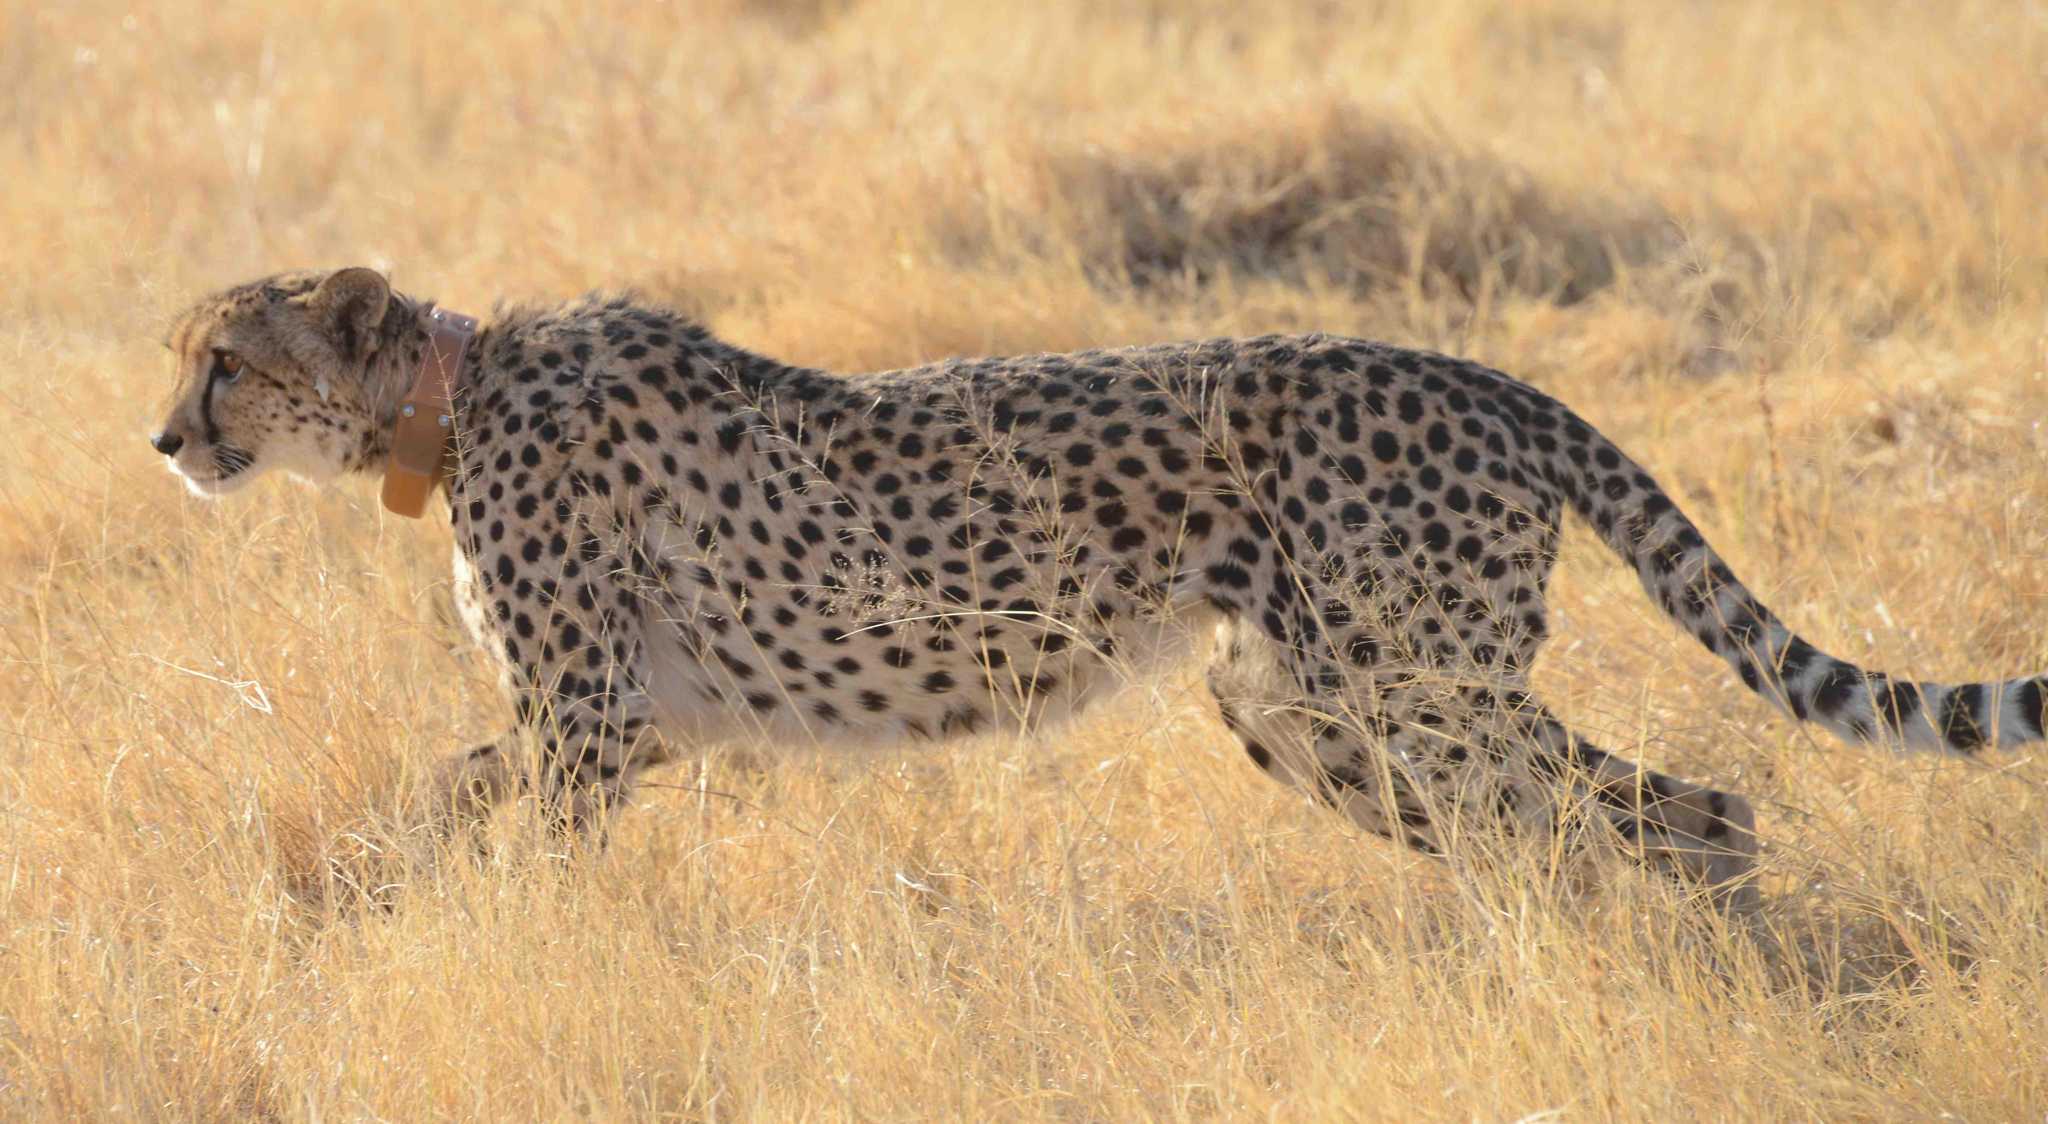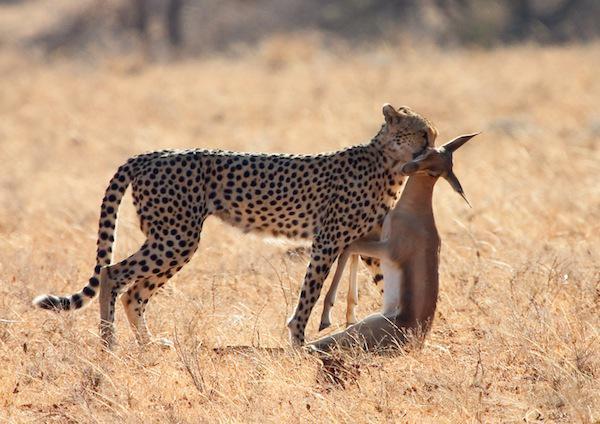The first image is the image on the left, the second image is the image on the right. Evaluate the accuracy of this statement regarding the images: "A cheetah is grabbing its prey from behind in the left image.". Is it true? Answer yes or no. No. The first image is the image on the left, the second image is the image on the right. Examine the images to the left and right. Is the description "An image shows a spotted wild cat jumping a horned animal from behind." accurate? Answer yes or no. No. 